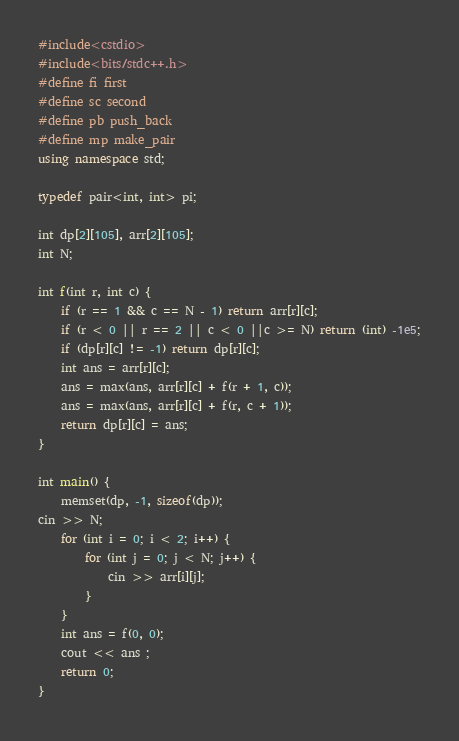Convert code to text. <code><loc_0><loc_0><loc_500><loc_500><_C++_>#include<cstdio>
#include<bits/stdc++.h>
#define fi first
#define sc second
#define pb push_back
#define mp make_pair
using namespace std;
 
typedef pair<int, int> pi;

int dp[2][105], arr[2][105];
int N;

int f(int r, int c) {
	if (r == 1 && c == N - 1) return arr[r][c];
	if (r < 0 || r == 2 || c < 0 ||c >= N) return (int) -1e5;
	if (dp[r][c] != -1) return dp[r][c];
	int ans = arr[r][c];
	ans = max(ans, arr[r][c] + f(r + 1, c));
	ans = max(ans, arr[r][c] + f(r, c + 1)); 
	return dp[r][c] = ans;
}

int main() {   
	memset(dp, -1, sizeof(dp));
cin >> N;
	for (int i = 0; i < 2; i++) {
		for (int j = 0; j < N; j++) {
			cin >> arr[i][j];
		}
	}
	int ans = f(0, 0);
	cout << ans ;
	return 0;
}</code> 